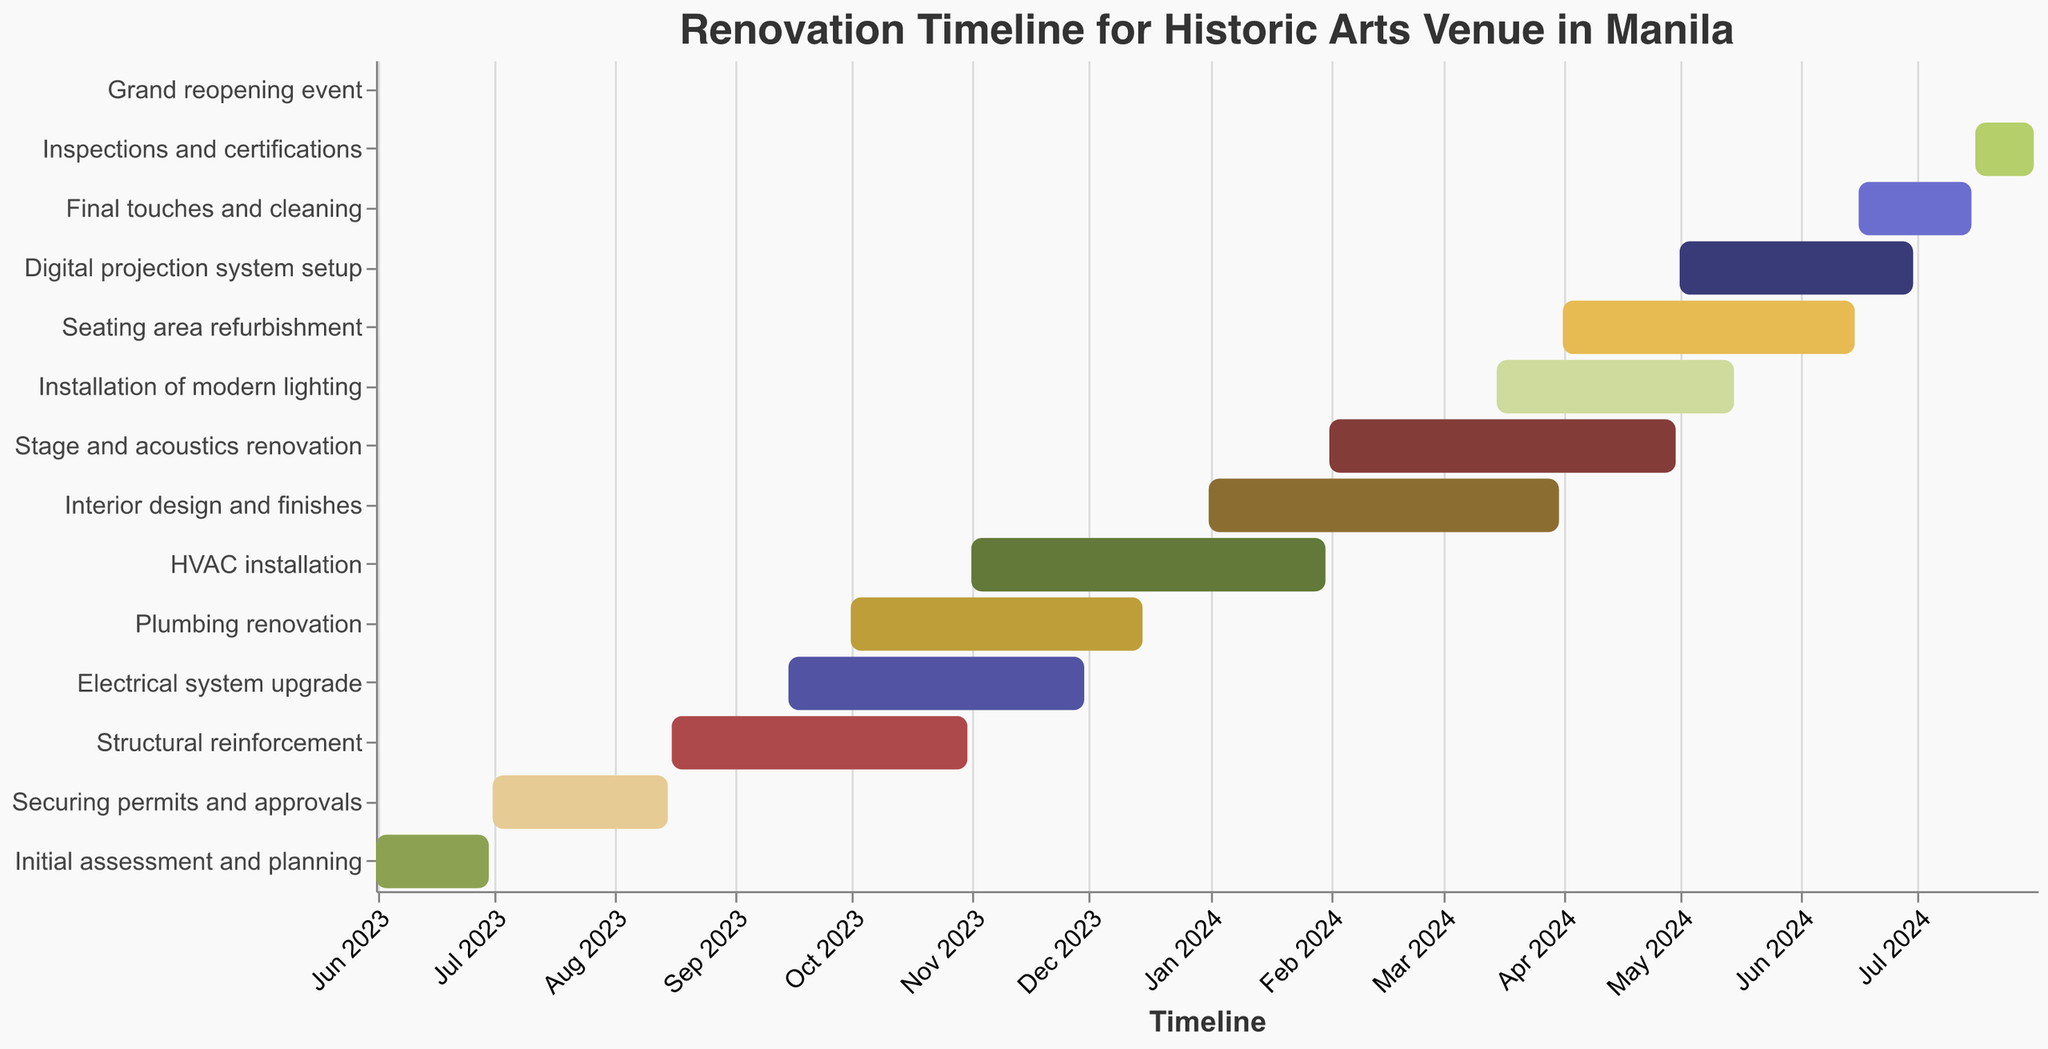What is the title of the figure? The title of the figure is usually found at the top, providing a brief description of the chart's content. Here, it indicates what the Gantt chart is about.
Answer: Renovation Timeline for Historic Arts Venue in Manila When does the "Initial assessment and planning" task start and end? The start and end dates for the "Initial assessment and planning" task can be seen on the timeline corresponding to this task.
Answer: June 1, 2023 - June 30, 2023 Which task starts immediately after "Securing permits and approvals"? To find the task starting immediately after "Securing permits and approvals," check the task listed next in time on the x-axis.
Answer: Structural reinforcement How long is the "Electrical system upgrade" task? Calculate the duration by finding the difference between the end and start dates.
Answer: 77 days Which task has the shortest duration? Compare the durations of all tasks by looking at the length of the bars in the Gantt chart. The one with the shortest length has the shortest duration.
Answer: Grand reopening event When will the “Interior design and finishes” task be completed? Look for the end date corresponding to the "Interior design and finishes" task.
Answer: March 31, 2024 What is the total duration from the start of "Initial assessment and planning" to the end of "Inspections and certifications"? Calculate the difference between the start date of "Initial assessment and planning" and the end date of "Inspections and certifications."
Answer: 425 days Does the "Digital projection system setup" overlap with the "Final touches and cleaning"? Check if the date ranges of the "Digital projection system setup" task and the "Final touches and cleaning" task overlap by comparing their periods.
Answer: Yes Which task directly precedes the "Grand reopening event"? Locate the task listed just before the "Grand reopening event" by considering the timeline.
Answer: Inspections and certifications Are there any tasks that extend into the year 2024? Look for tasks that have end dates in the year 2024.
Answer: Yes (HVAC installation, Interior design and finishes, Stage and acoustics renovation, Installation of modern lighting, Seating area refurbishment, Digital projection system setup, Final touches and cleaning, Inspections and certifications, Grand reopening event) 